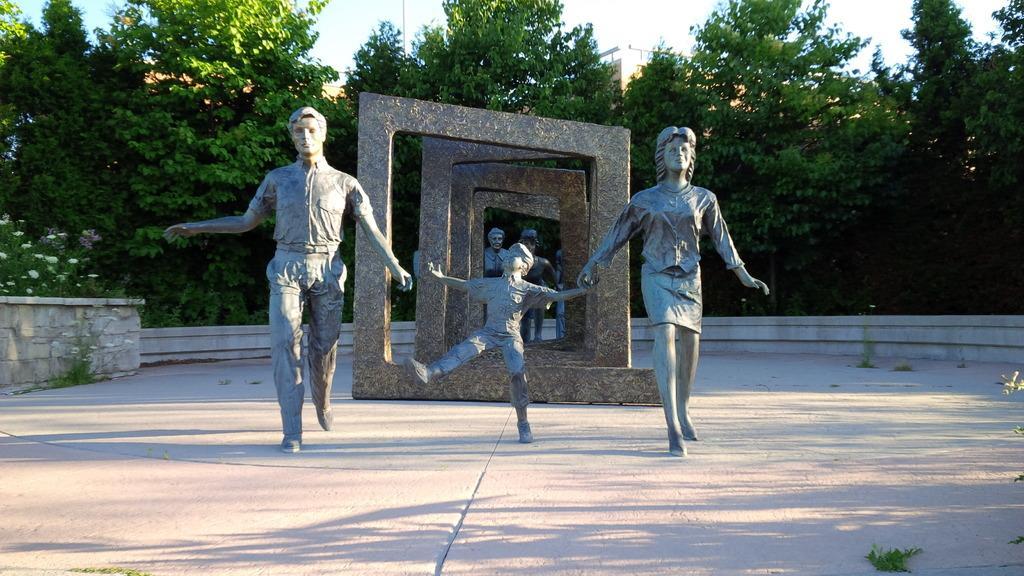Can you describe this image briefly? In front of the image there are statues and arch structures. In the background of the image there are trees, buildings. 